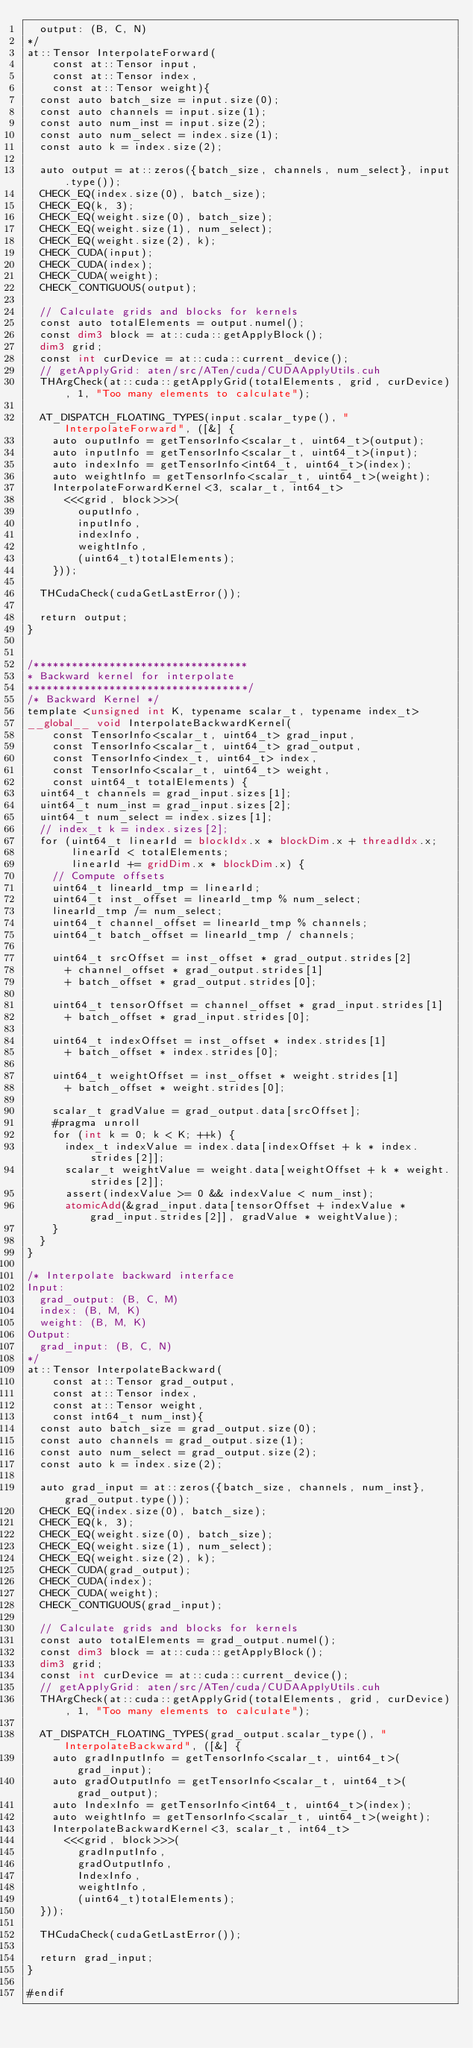<code> <loc_0><loc_0><loc_500><loc_500><_Cuda_>  output: (B, C, N)
*/
at::Tensor InterpolateForward(
    const at::Tensor input,
    const at::Tensor index,
    const at::Tensor weight){
  const auto batch_size = input.size(0);
  const auto channels = input.size(1);
  const auto num_inst = input.size(2);
  const auto num_select = index.size(1);
  const auto k = index.size(2);

  auto output = at::zeros({batch_size, channels, num_select}, input.type());
  CHECK_EQ(index.size(0), batch_size);
  CHECK_EQ(k, 3);
  CHECK_EQ(weight.size(0), batch_size);
  CHECK_EQ(weight.size(1), num_select);
  CHECK_EQ(weight.size(2), k);
  CHECK_CUDA(input);
  CHECK_CUDA(index);
  CHECK_CUDA(weight);
  CHECK_CONTIGUOUS(output);

  // Calculate grids and blocks for kernels 
  const auto totalElements = output.numel();
  const dim3 block = at::cuda::getApplyBlock();
  dim3 grid;
  const int curDevice = at::cuda::current_device();
  // getApplyGrid: aten/src/ATen/cuda/CUDAApplyUtils.cuh
  THArgCheck(at::cuda::getApplyGrid(totalElements, grid, curDevice), 1, "Too many elements to calculate");

  AT_DISPATCH_FLOATING_TYPES(input.scalar_type(), "InterpolateForward", ([&] {
    auto ouputInfo = getTensorInfo<scalar_t, uint64_t>(output);
    auto inputInfo = getTensorInfo<scalar_t, uint64_t>(input);
    auto indexInfo = getTensorInfo<int64_t, uint64_t>(index);
    auto weightInfo = getTensorInfo<scalar_t, uint64_t>(weight);
    InterpolateForwardKernel<3, scalar_t, int64_t>
      <<<grid, block>>>(
        ouputInfo,
        inputInfo,
        indexInfo,
        weightInfo,
        (uint64_t)totalElements);
    }));
  
  THCudaCheck(cudaGetLastError());

  return output;
}  


/**********************************
* Backward kernel for interpolate 
***********************************/
/* Backward Kernel */
template <unsigned int K, typename scalar_t, typename index_t>
__global__ void InterpolateBackwardKernel(
    const TensorInfo<scalar_t, uint64_t> grad_input,
    const TensorInfo<scalar_t, uint64_t> grad_output,
    const TensorInfo<index_t, uint64_t> index,
    const TensorInfo<scalar_t, uint64_t> weight,
    const uint64_t totalElements) {
  uint64_t channels = grad_input.sizes[1];
  uint64_t num_inst = grad_input.sizes[2];
  uint64_t num_select = index.sizes[1];
  // index_t k = index.sizes[2];
  for (uint64_t linearId = blockIdx.x * blockDim.x + threadIdx.x;
       linearId < totalElements;
       linearId += gridDim.x * blockDim.x) {
    // Compute offsets
    uint64_t linearId_tmp = linearId;
    uint64_t inst_offset = linearId_tmp % num_select;
    linearId_tmp /= num_select;
    uint64_t channel_offset = linearId_tmp % channels;
    uint64_t batch_offset = linearId_tmp / channels;
    
    uint64_t srcOffset = inst_offset * grad_output.strides[2]
      + channel_offset * grad_output.strides[1]
      + batch_offset * grad_output.strides[0];

    uint64_t tensorOffset = channel_offset * grad_input.strides[1]
      + batch_offset * grad_input.strides[0];
    
    uint64_t indexOffset = inst_offset * index.strides[1]
      + batch_offset * index.strides[0];

    uint64_t weightOffset = inst_offset * weight.strides[1]
      + batch_offset * weight.strides[0];

    scalar_t gradValue = grad_output.data[srcOffset];
    #pragma unroll
    for (int k = 0; k < K; ++k) {
      index_t indexValue = index.data[indexOffset + k * index.strides[2]];
      scalar_t weightValue = weight.data[weightOffset + k * weight.strides[2]];
      assert(indexValue >= 0 && indexValue < num_inst);
      atomicAdd(&grad_input.data[tensorOffset + indexValue * grad_input.strides[2]], gradValue * weightValue);
    }
  }
}

/* Interpolate backward interface
Input:
  grad_output: (B, C, M)
  index: (B, M, K)
  weight: (B, M, K)
Output:
  grad_input: (B, C, N)
*/
at::Tensor InterpolateBackward(
    const at::Tensor grad_output,
    const at::Tensor index,
    const at::Tensor weight,
    const int64_t num_inst){
  const auto batch_size = grad_output.size(0);
  const auto channels = grad_output.size(1);
  const auto num_select = grad_output.size(2);
  const auto k = index.size(2);

  auto grad_input = at::zeros({batch_size, channels, num_inst}, grad_output.type());
  CHECK_EQ(index.size(0), batch_size);
  CHECK_EQ(k, 3);
  CHECK_EQ(weight.size(0), batch_size);
  CHECK_EQ(weight.size(1), num_select);
  CHECK_EQ(weight.size(2), k);
  CHECK_CUDA(grad_output);
  CHECK_CUDA(index);
  CHECK_CUDA(weight);
  CHECK_CONTIGUOUS(grad_input);

  // Calculate grids and blocks for kernels 
  const auto totalElements = grad_output.numel();
  const dim3 block = at::cuda::getApplyBlock();
  dim3 grid;
  const int curDevice = at::cuda::current_device();
  // getApplyGrid: aten/src/ATen/cuda/CUDAApplyUtils.cuh
  THArgCheck(at::cuda::getApplyGrid(totalElements, grid, curDevice), 1, "Too many elements to calculate");

  AT_DISPATCH_FLOATING_TYPES(grad_output.scalar_type(), "InterpolateBackward", ([&] {
    auto gradInputInfo = getTensorInfo<scalar_t, uint64_t>(grad_input);
    auto gradOutputInfo = getTensorInfo<scalar_t, uint64_t>(grad_output);
    auto IndexInfo = getTensorInfo<int64_t, uint64_t>(index);
    auto weightInfo = getTensorInfo<scalar_t, uint64_t>(weight);
    InterpolateBackwardKernel<3, scalar_t, int64_t>
      <<<grid, block>>>(
        gradInputInfo,
        gradOutputInfo,
        IndexInfo,
        weightInfo,
        (uint64_t)totalElements);
  }));

  THCudaCheck(cudaGetLastError());

  return grad_input;
}

#endif
</code> 